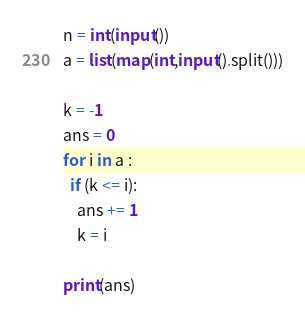Convert code to text. <code><loc_0><loc_0><loc_500><loc_500><_Python_>n = int(input())
a = list(map(int,input().split()))

k = -1
ans = 0
for i in a :
  if (k <= i):
    ans += 1
    k = i
         
print(ans)
</code> 